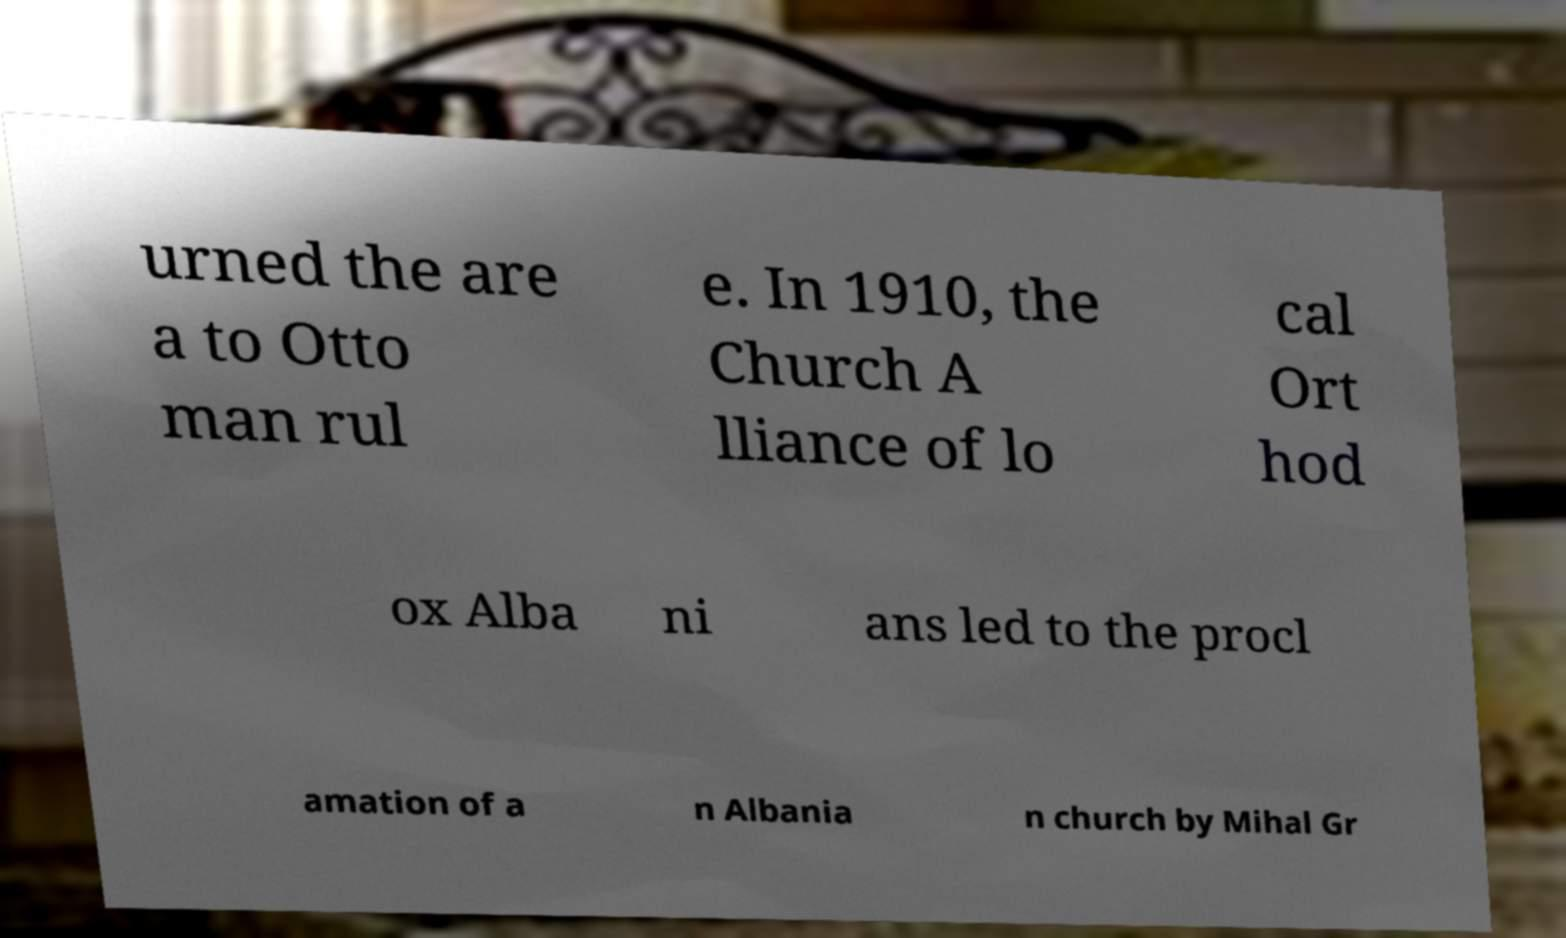Please identify and transcribe the text found in this image. urned the are a to Otto man rul e. In 1910, the Church A lliance of lo cal Ort hod ox Alba ni ans led to the procl amation of a n Albania n church by Mihal Gr 